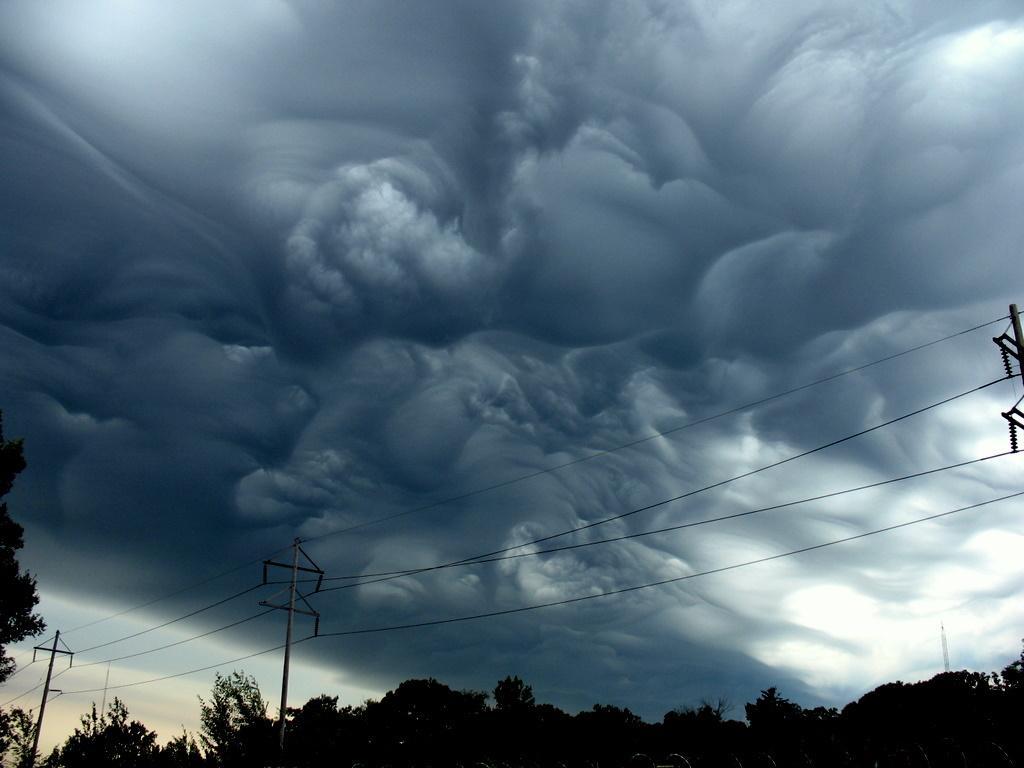Describe this image in one or two sentences. In this picture we can see trees and current poles with wires. We can see sky is cloudy. 